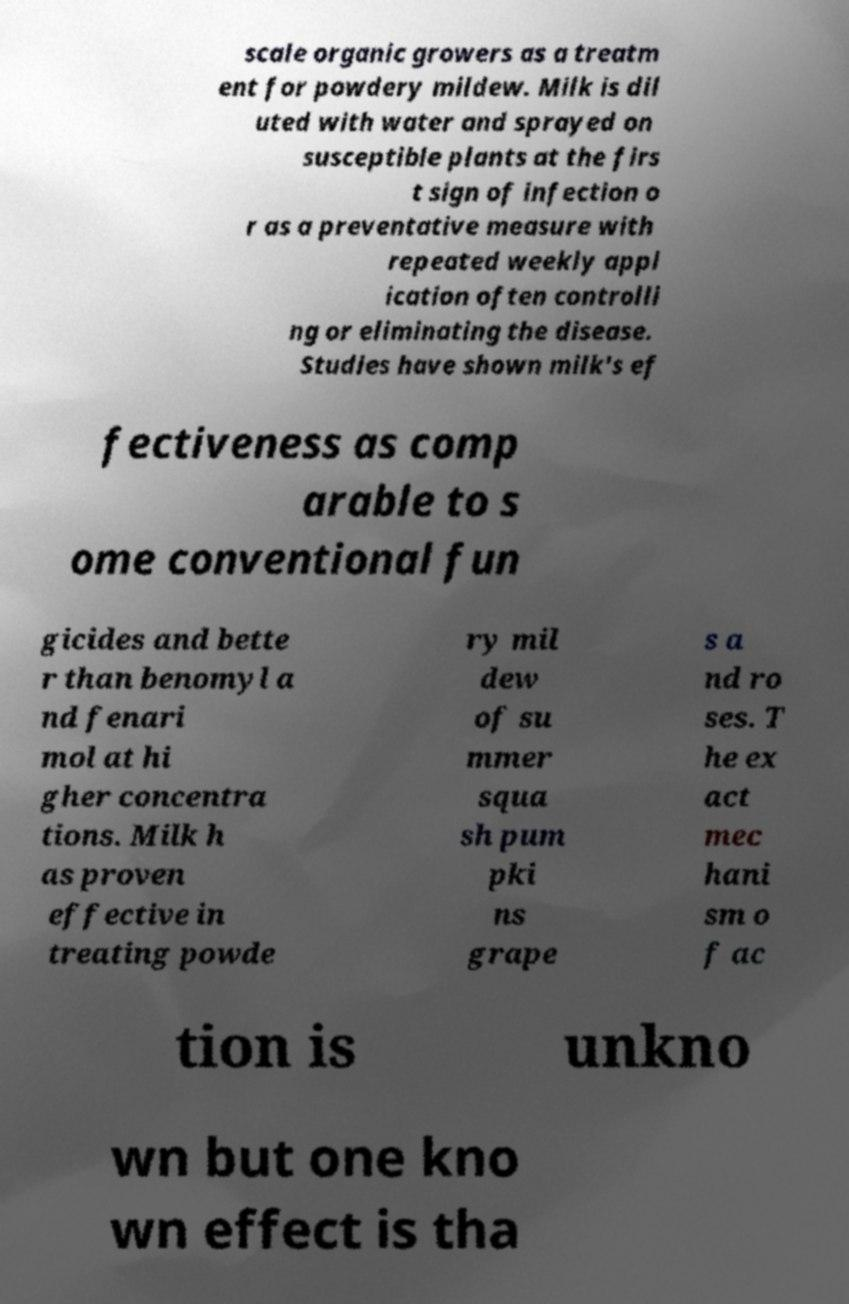Please identify and transcribe the text found in this image. scale organic growers as a treatm ent for powdery mildew. Milk is dil uted with water and sprayed on susceptible plants at the firs t sign of infection o r as a preventative measure with repeated weekly appl ication often controlli ng or eliminating the disease. Studies have shown milk's ef fectiveness as comp arable to s ome conventional fun gicides and bette r than benomyl a nd fenari mol at hi gher concentra tions. Milk h as proven effective in treating powde ry mil dew of su mmer squa sh pum pki ns grape s a nd ro ses. T he ex act mec hani sm o f ac tion is unkno wn but one kno wn effect is tha 